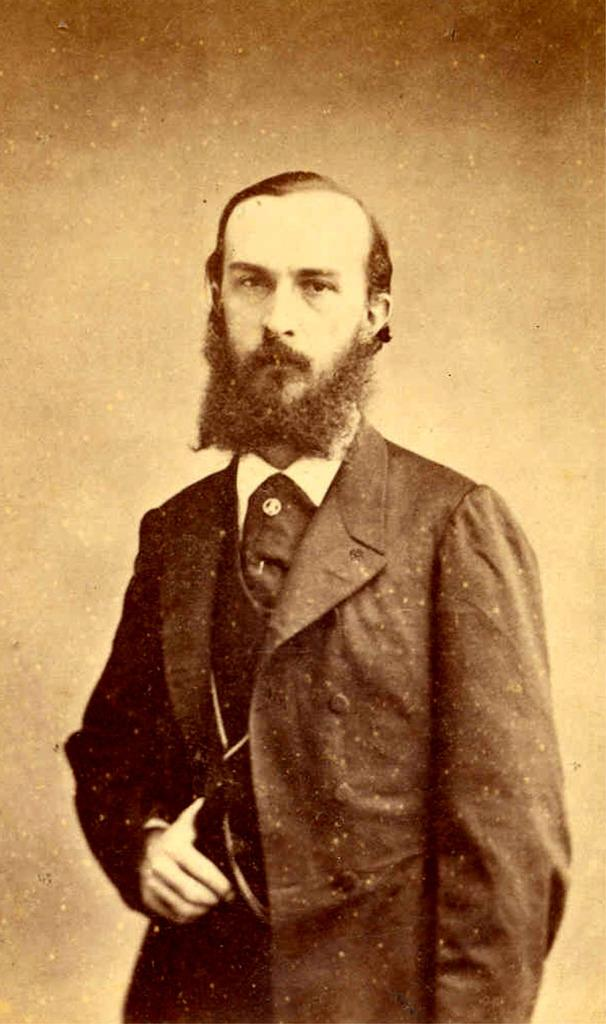What is the main subject in the foreground of the image? There is a man in the foreground of the image. What is the man wearing? The man is wearing a suit. Can you describe the man's posture or action in the image? The man has his thumb in between the shirt buttons. What colors can be seen in the background of the image? The background of the image is cream and brown. How many icicles are hanging from the man's suit in the image? There are no icicles present in the image; the man is wearing a suit in a cream and brown background. 